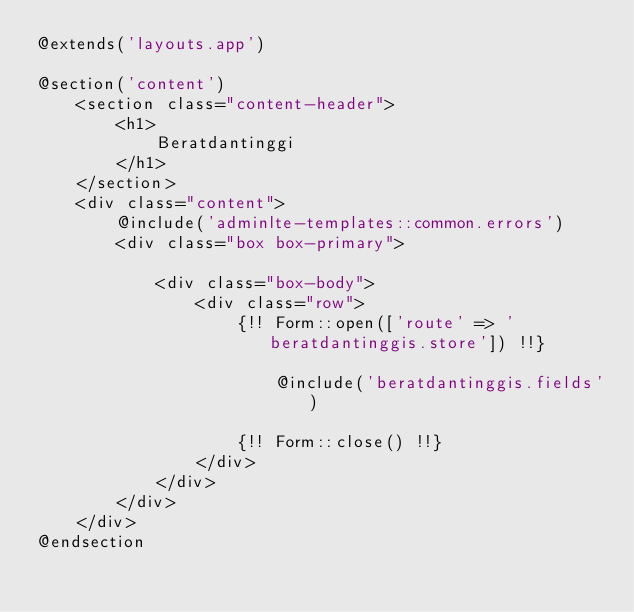<code> <loc_0><loc_0><loc_500><loc_500><_PHP_>@extends('layouts.app')

@section('content')
    <section class="content-header">
        <h1>
            Beratdantinggi
        </h1>
    </section>
    <div class="content">
        @include('adminlte-templates::common.errors')
        <div class="box box-primary">

            <div class="box-body">
                <div class="row">
                    {!! Form::open(['route' => 'beratdantinggis.store']) !!}

                        @include('beratdantinggis.fields')

                    {!! Form::close() !!}
                </div>
            </div>
        </div>
    </div>
@endsection
</code> 